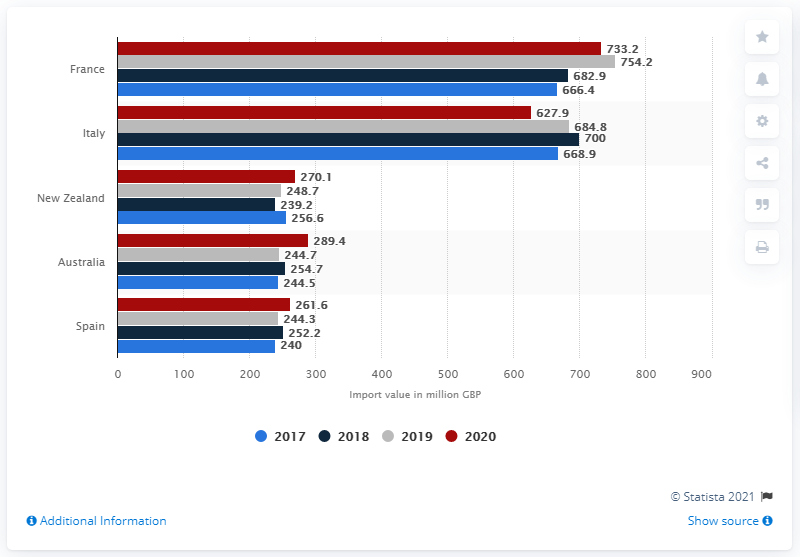Outline some significant characteristics in this image. Of the wine imported from France, 733.2% came from France alone. 